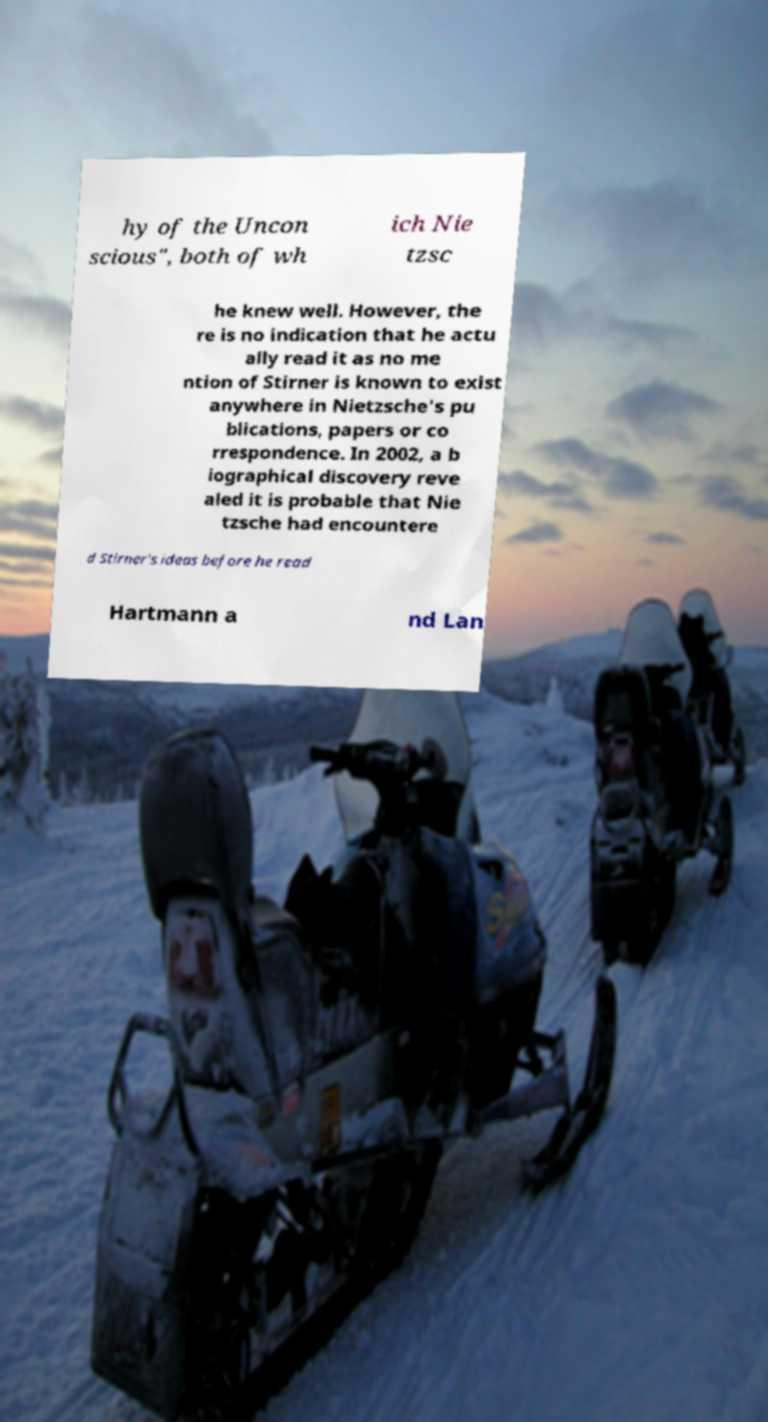I need the written content from this picture converted into text. Can you do that? hy of the Uncon scious", both of wh ich Nie tzsc he knew well. However, the re is no indication that he actu ally read it as no me ntion of Stirner is known to exist anywhere in Nietzsche's pu blications, papers or co rrespondence. In 2002, a b iographical discovery reve aled it is probable that Nie tzsche had encountere d Stirner's ideas before he read Hartmann a nd Lan 